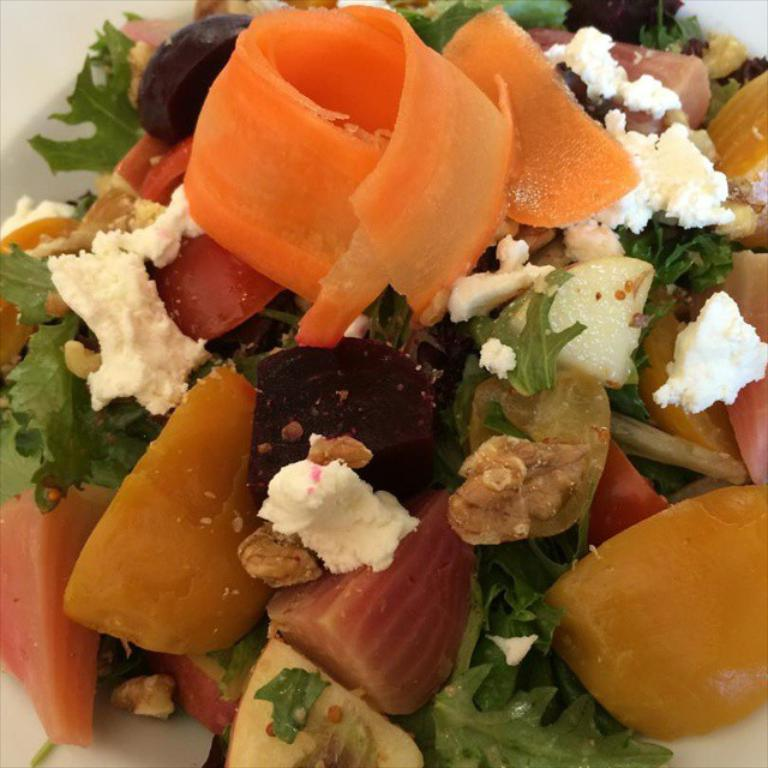What is the main subject of the image? The main subject of the image is a group of food items. Where are the food items located in the image? The food items are on a plate. What type of badge is visible on the plate in the image? There is no badge present on the plate in the image. How does the food on the plate contribute to pollution in the image? There is no indication of pollution in the image, and the food on the plate is not contributing to any pollution. 